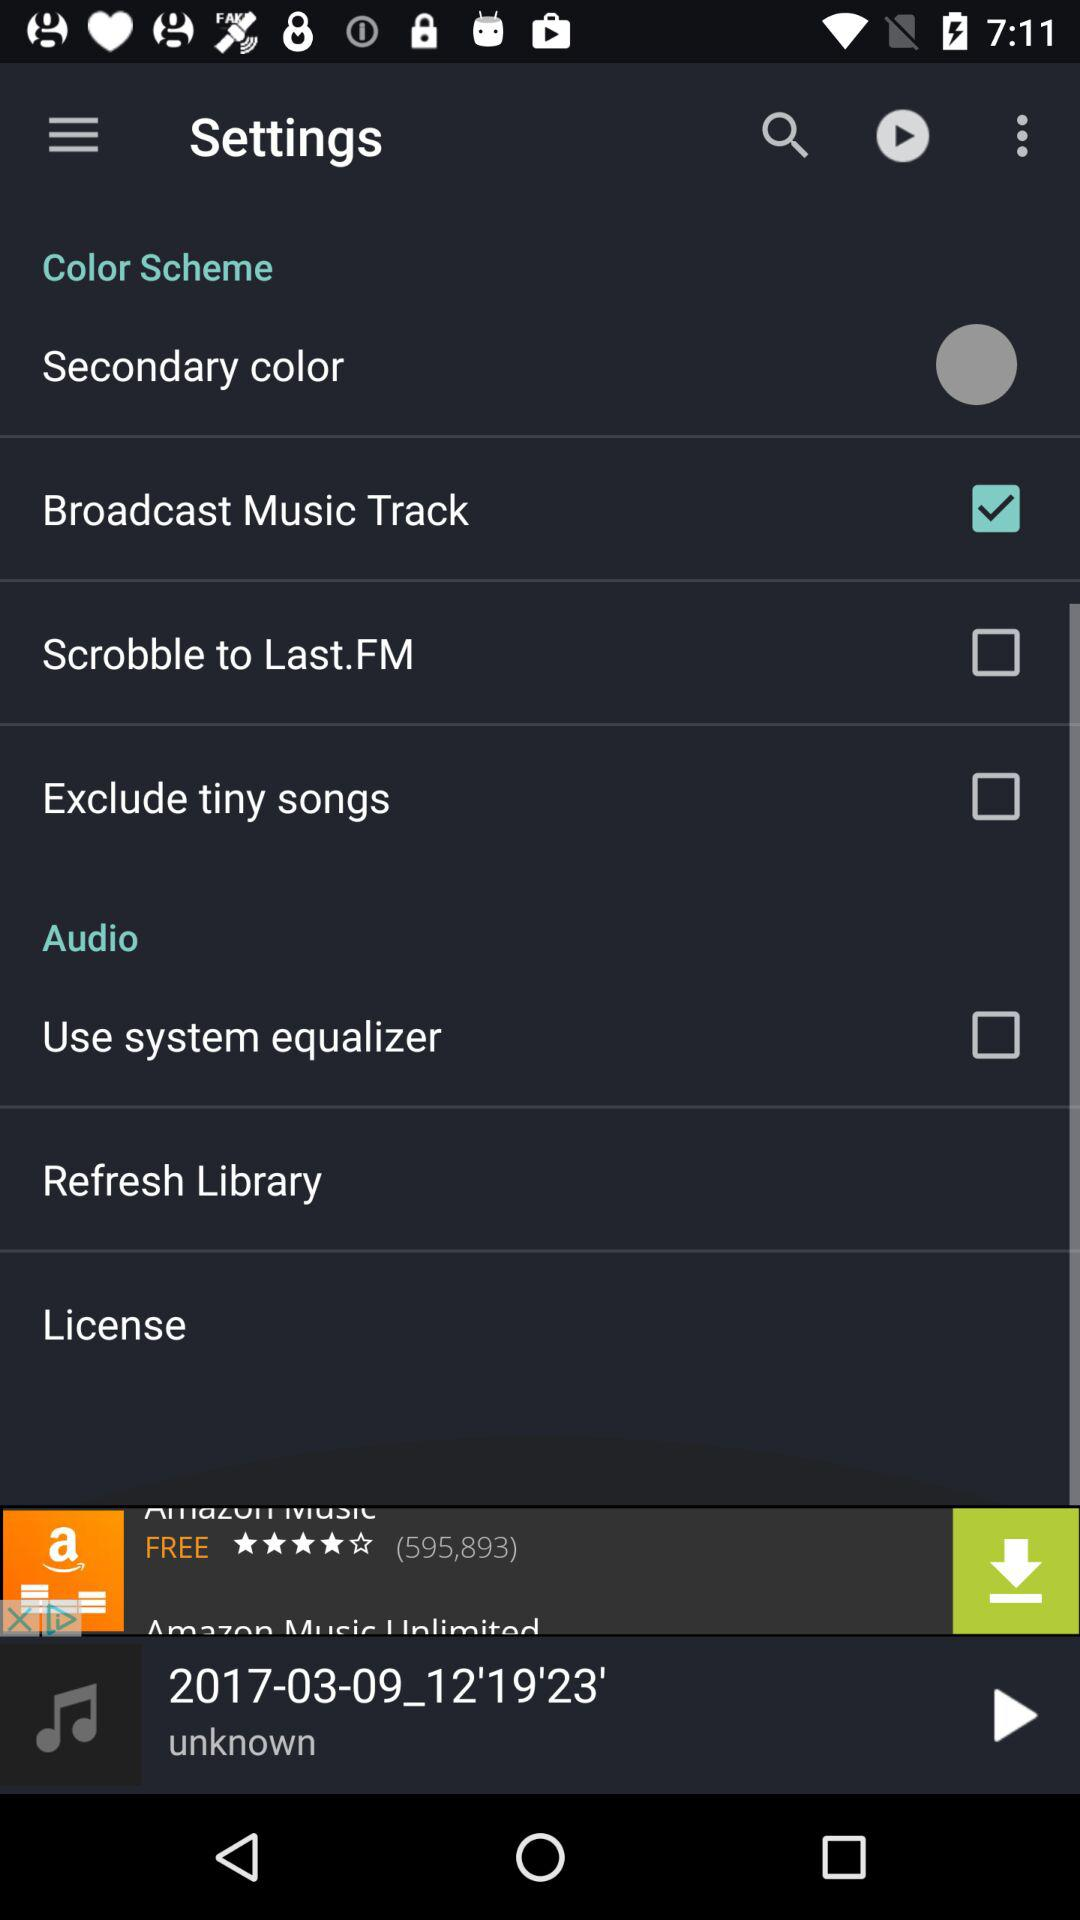What is the name of the currently playing album? The album is 2017-03-09_12'19'23'. 